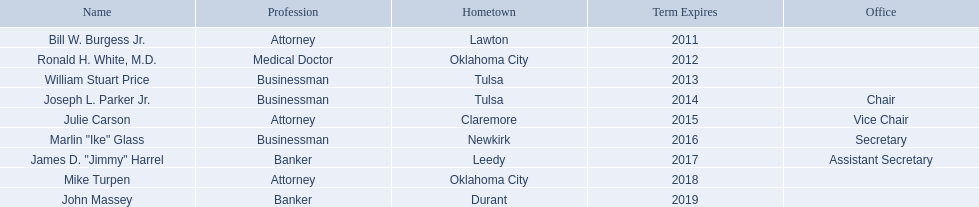Who are the state regents? Bill W. Burgess Jr., Ronald H. White, M.D., William Stuart Price, Joseph L. Parker Jr., Julie Carson, Marlin "Ike" Glass, James D. "Jimmy" Harrel, Mike Turpen, John Massey. Of those state regents, who is from the same hometown as ronald h. white, m.d.? Mike Turpen. What is the origin of bill w. burgess jr.? Lawton. What is the hometown of price and parker? Tulsa. Who originates from the same state as white? Mike Turpen. 